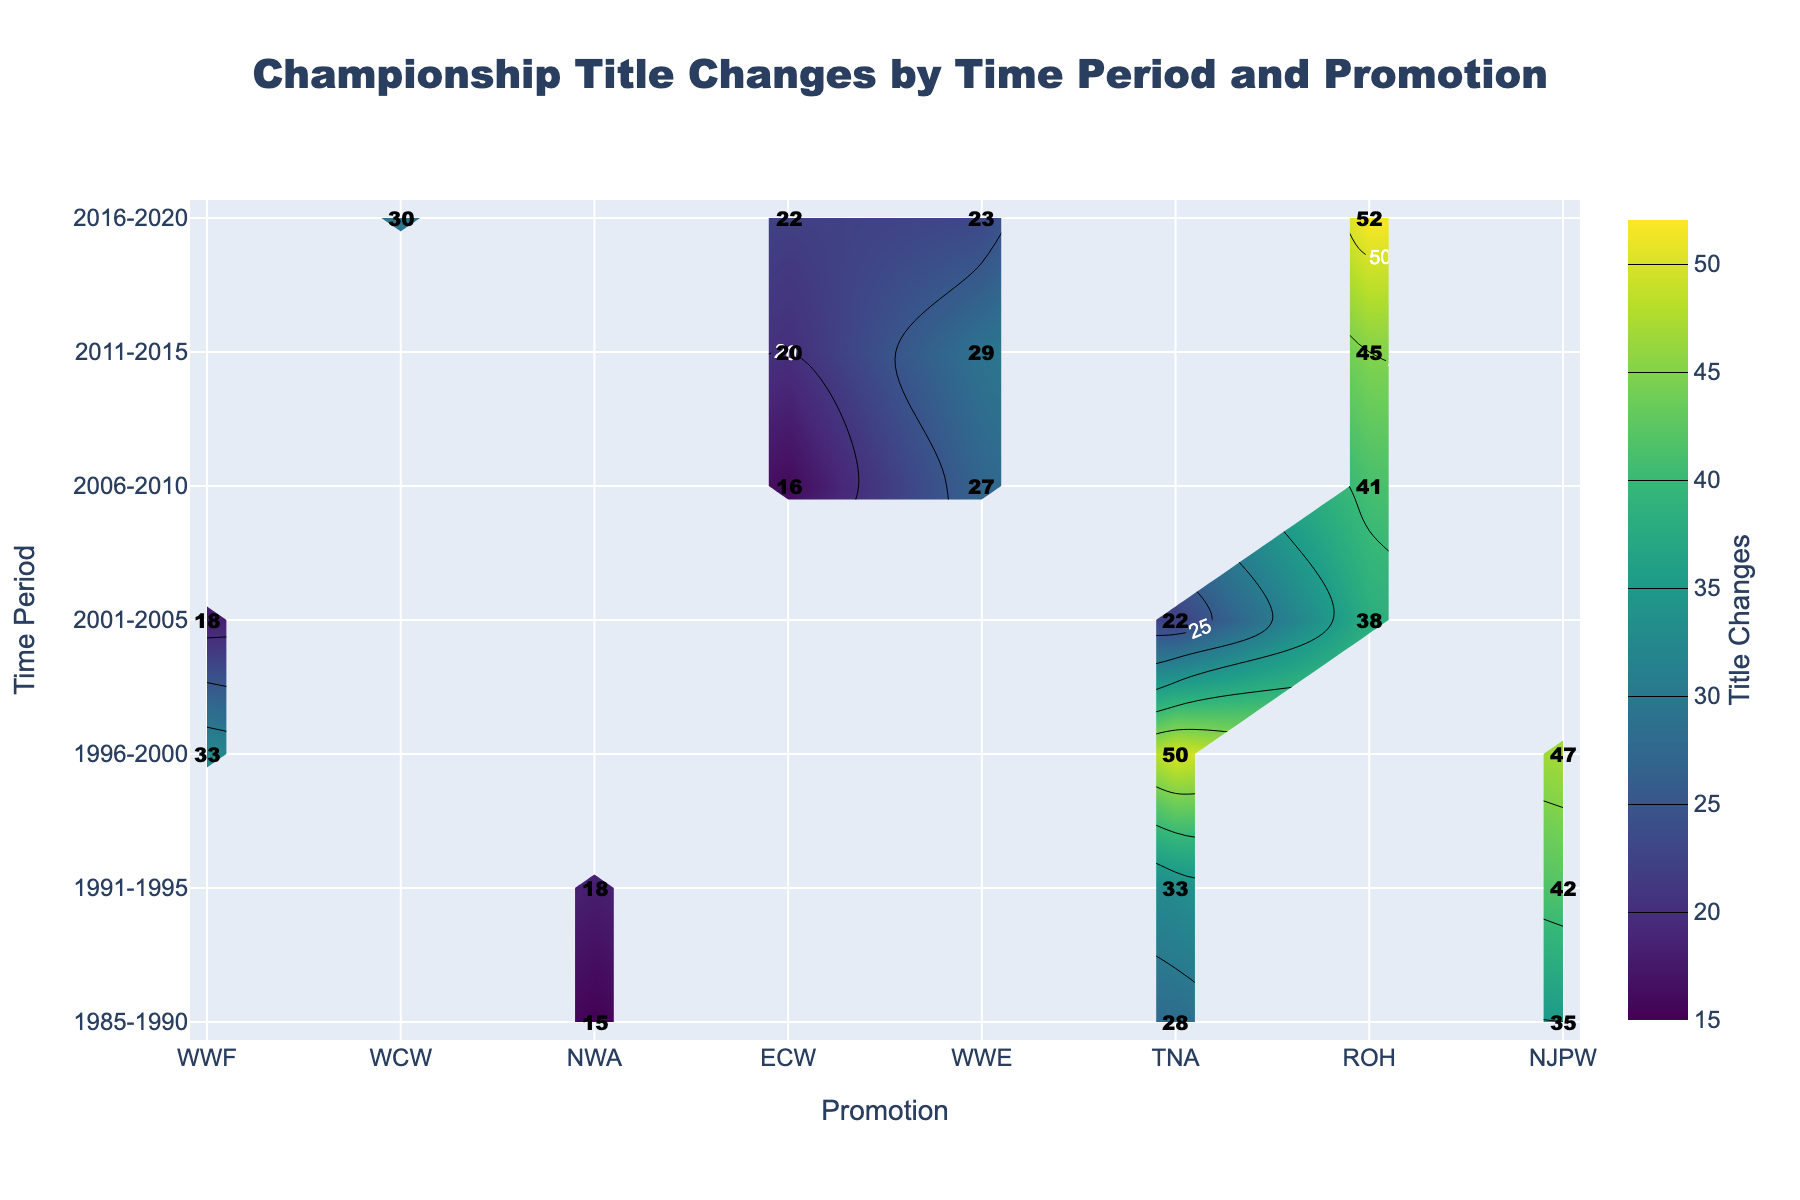What is the title of the plot? The title is located at the top of the figure and is clearly stated in a large font. It is placed within the layout specified for the plot.
Answer: Championship Title Changes by Time Period and Promotion Which promotion had the most title changes in the period 2016-2020? Look at the y-axis for the period 2016-2020 and follow the contour plot horizontally to find the promotion with the highest value. The labels on the contours indicate that WWE has the highest value.
Answer: WWE How many title changes did the WWF have between 1996 and 2000? Locate the 1996-2000 row on the y-axis and follow it horizontally until you reach the column for WWF. The contour label indicates the number of title changes.
Answer: 47 Which promotion had the least title changes in the period 1985-1990? Locate the 1985-1990 period on the y-axis and compare the title change values across promotions. The contour labels indicate that NWA has the lowest number.
Answer: NWA 